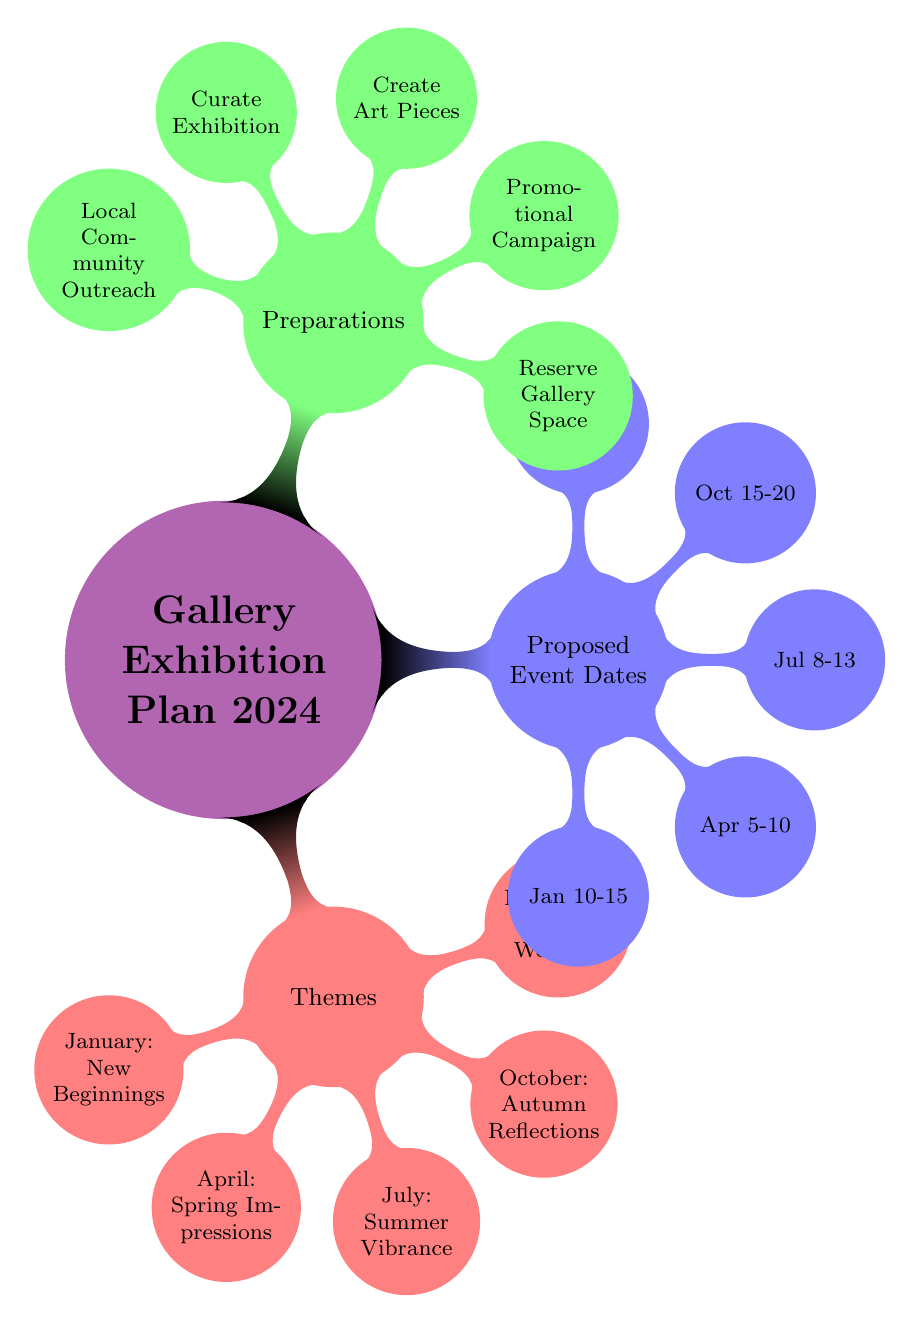What is the theme for December? The diagram lists "Themes" as a main node, with "December: Winter Wonders" as a child node under it.
Answer: Winter Wonders How many themes are proposed for the exhibitions? The "Themes" node has five child nodes representing the various monthly themes. Therefore, there are five themes proposed for the exhibitions.
Answer: 5 What is the date for the Summer Vibrance exhibition? The "Proposed Event Dates" node has a child node corresponding to "July," which indicates "Jul 8-13" as the date for the Summer Vibrance exhibition.
Answer: Jul 8-13 Which preparation is needed for each event? The "Preparations" node has five child nodes, each listing an essential task. All these preparations are needed for hosting the exhibitions efficiently.
Answer: Reserve Gallery Space, Promotional Campaign, Create Art Pieces, Curate Exhibition, Local Community Outreach What is the theme for the event on April? The node for "April" under "Themes" states "Spring Impressions." This indicates the thematic focus of the exhibition scheduled for that month.
Answer: Spring Impressions What is the relationship between the January theme and its proposed date? The node for "January" under "Themes" is directly linked to the child node "Jan 10-15" under "Proposed Event Dates," showing that the event with the theme of New Beginnings takes place during that date range.
Answer: New Beginnings - Jan 10-15 Which month has a gallery event focusing on Autumn? The "Themes" node includes "October: Autumn Reflections," linking October directly to the autumn-themed exhibition planned for that month.
Answer: October What are the colors used for the "Preparations" node? The "Preparations" main node is represented using the concept color green!50, which can be found in the style settings of the diagram.
Answer: Green 